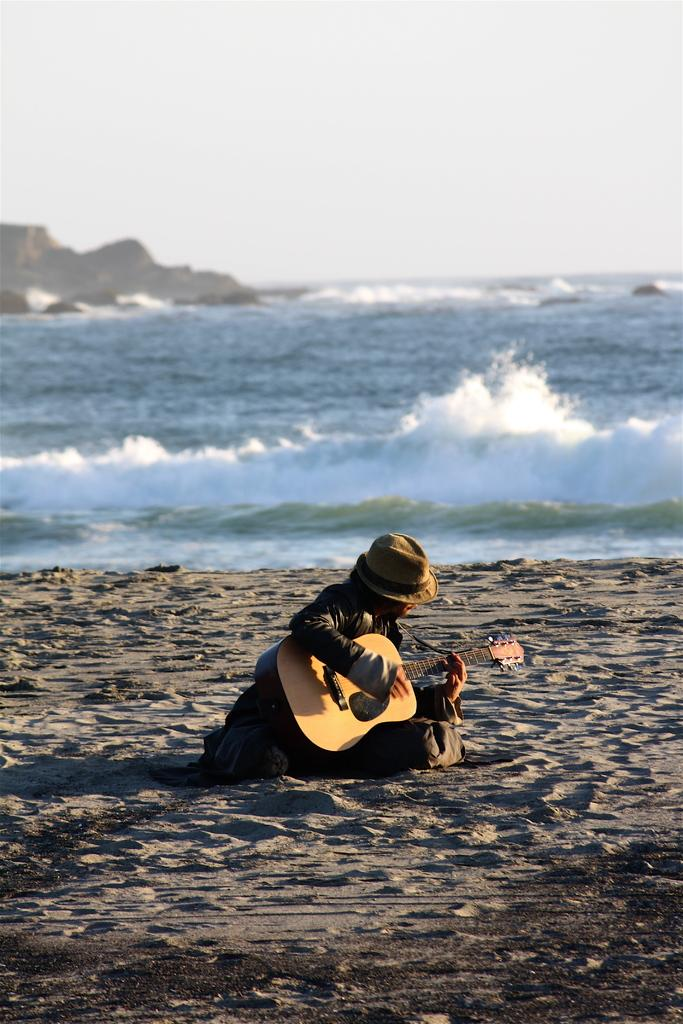What is the person in the image doing? The person is sitting in the image and holding a guitar. What object can be seen near the person? There is a cap in the image. What type of environment is depicted in the image? The image features sand, water, and a rock, suggesting a beach or coastal setting. What is the color of the sky in the image? The sky is white in the image. Where is the person's aunt in the image? There is no mention of an aunt in the image, so it cannot be determined where she is. 